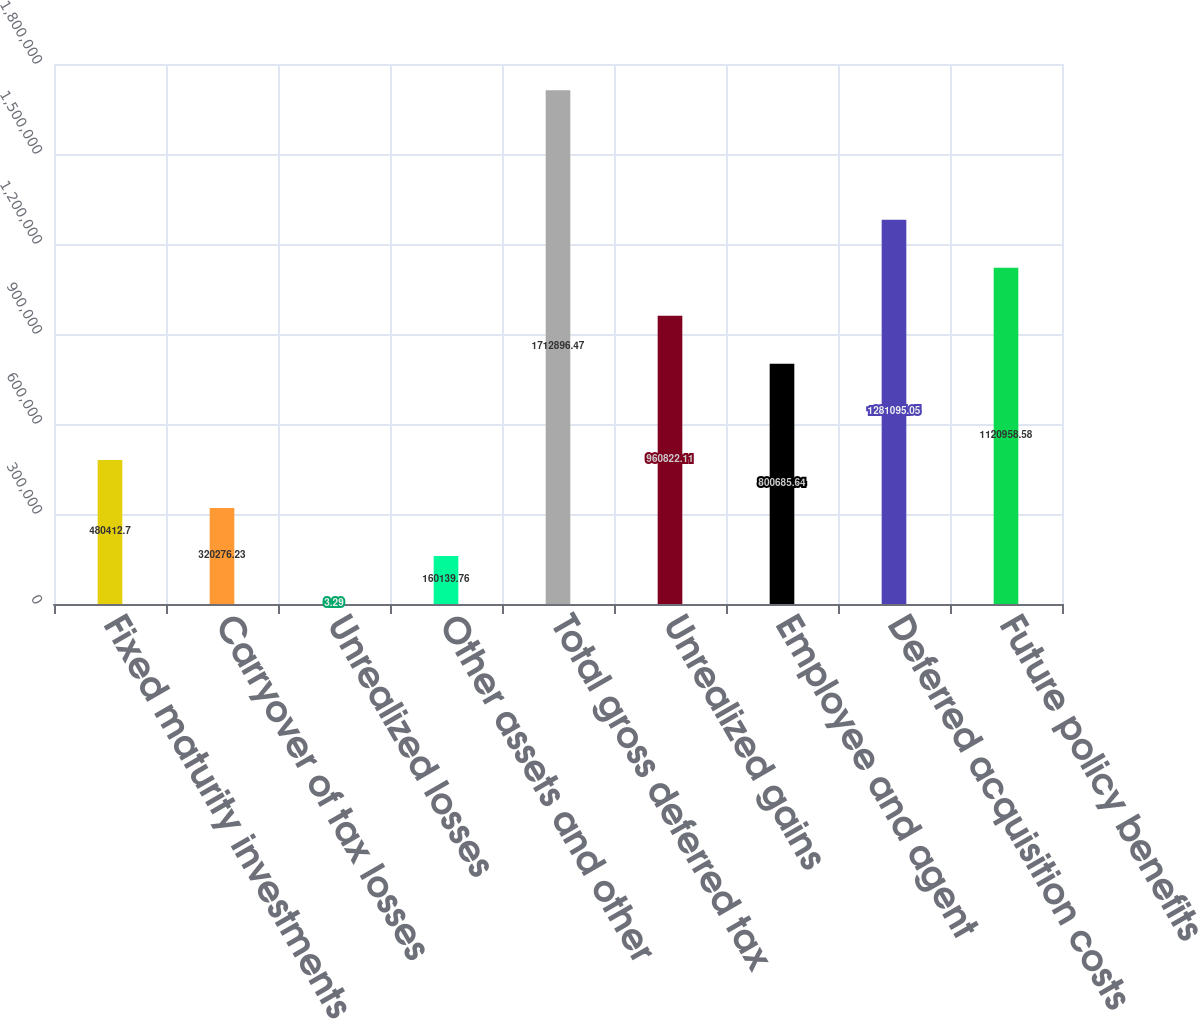Convert chart. <chart><loc_0><loc_0><loc_500><loc_500><bar_chart><fcel>Fixed maturity investments<fcel>Carryover of tax losses<fcel>Unrealized losses<fcel>Other assets and other<fcel>Total gross deferred tax<fcel>Unrealized gains<fcel>Employee and agent<fcel>Deferred acquisition costs<fcel>Future policy benefits<nl><fcel>480413<fcel>320276<fcel>3.29<fcel>160140<fcel>1.7129e+06<fcel>960822<fcel>800686<fcel>1.2811e+06<fcel>1.12096e+06<nl></chart> 